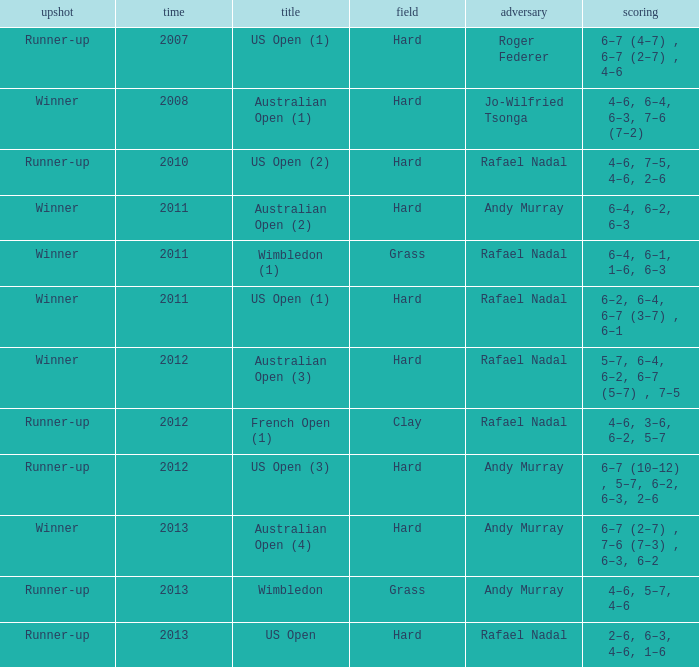What surface was the Australian Open (1) played on? Hard. 